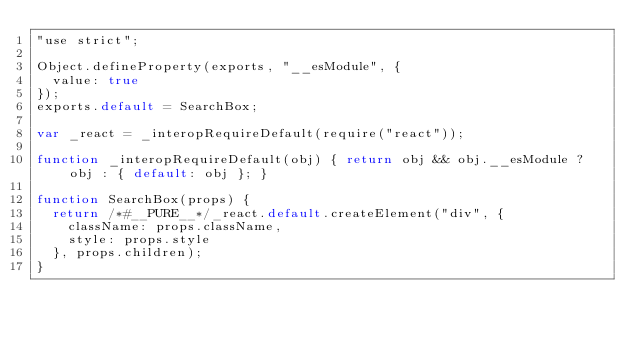Convert code to text. <code><loc_0><loc_0><loc_500><loc_500><_JavaScript_>"use strict";

Object.defineProperty(exports, "__esModule", {
  value: true
});
exports.default = SearchBox;

var _react = _interopRequireDefault(require("react"));

function _interopRequireDefault(obj) { return obj && obj.__esModule ? obj : { default: obj }; }

function SearchBox(props) {
  return /*#__PURE__*/_react.default.createElement("div", {
    className: props.className,
    style: props.style
  }, props.children);
}</code> 